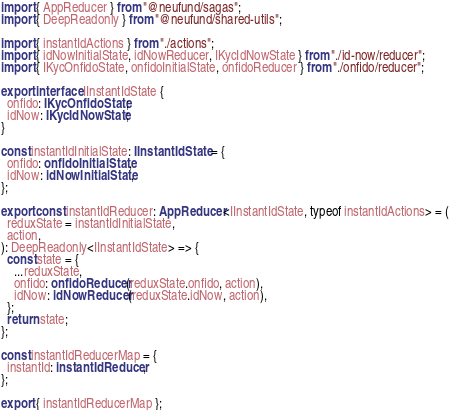Convert code to text. <code><loc_0><loc_0><loc_500><loc_500><_TypeScript_>import { AppReducer } from "@neufund/sagas";
import { DeepReadonly } from "@neufund/shared-utils";

import { instantIdActions } from "./actions";
import { idNowInitialState, idNowReducer, IKycIdNowState } from "./id-now/reducer";
import { IKycOnfidoState, onfidoInitialState, onfidoReducer } from "./onfido/reducer";

export interface IInstantIdState {
  onfido: IKycOnfidoState;
  idNow: IKycIdNowState;
}

const instantIdInitialState: IInstantIdState = {
  onfido: onfidoInitialState,
  idNow: idNowInitialState,
};

export const instantIdReducer: AppReducer<IInstantIdState, typeof instantIdActions> = (
  reduxState = instantIdInitialState,
  action,
): DeepReadonly<IInstantIdState> => {
  const state = {
    ...reduxState,
    onfido: onfidoReducer(reduxState.onfido, action),
    idNow: idNowReducer(reduxState.idNow, action),
  };
  return state;
};

const instantIdReducerMap = {
  instantId: instantIdReducer,
};

export { instantIdReducerMap };
</code> 